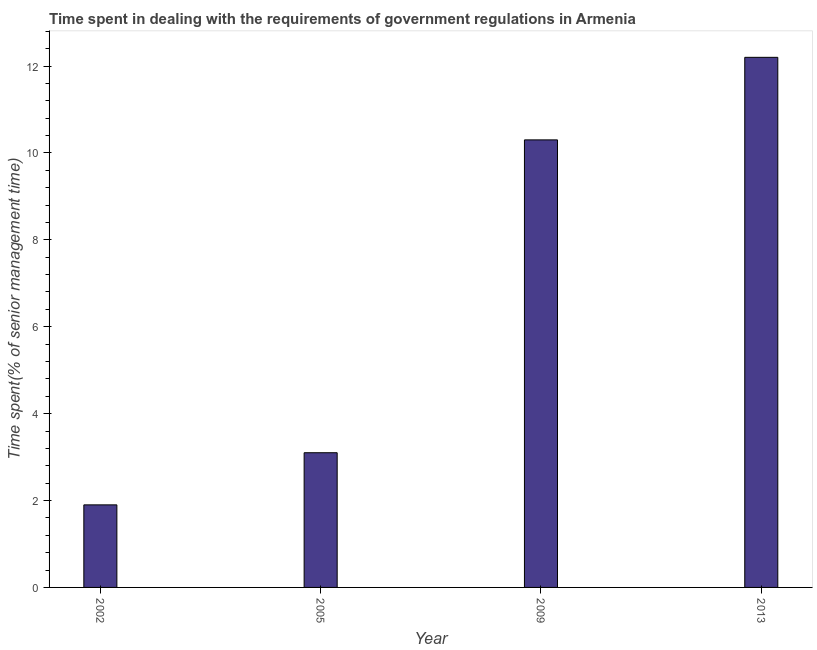Does the graph contain any zero values?
Provide a short and direct response. No. Does the graph contain grids?
Make the answer very short. No. What is the title of the graph?
Your answer should be very brief. Time spent in dealing with the requirements of government regulations in Armenia. What is the label or title of the X-axis?
Your response must be concise. Year. What is the label or title of the Y-axis?
Offer a very short reply. Time spent(% of senior management time). Across all years, what is the maximum time spent in dealing with government regulations?
Your response must be concise. 12.2. In which year was the time spent in dealing with government regulations minimum?
Give a very brief answer. 2002. What is the average time spent in dealing with government regulations per year?
Keep it short and to the point. 6.88. What is the median time spent in dealing with government regulations?
Offer a very short reply. 6.7. Do a majority of the years between 2009 and 2013 (inclusive) have time spent in dealing with government regulations greater than 12 %?
Offer a very short reply. No. What is the ratio of the time spent in dealing with government regulations in 2002 to that in 2005?
Offer a very short reply. 0.61. Is the time spent in dealing with government regulations in 2009 less than that in 2013?
Make the answer very short. Yes. Is the difference between the time spent in dealing with government regulations in 2005 and 2009 greater than the difference between any two years?
Offer a terse response. No. Is the sum of the time spent in dealing with government regulations in 2005 and 2009 greater than the maximum time spent in dealing with government regulations across all years?
Offer a very short reply. Yes. In how many years, is the time spent in dealing with government regulations greater than the average time spent in dealing with government regulations taken over all years?
Keep it short and to the point. 2. How many years are there in the graph?
Your answer should be compact. 4. What is the Time spent(% of senior management time) in 2002?
Offer a terse response. 1.9. What is the Time spent(% of senior management time) of 2009?
Offer a very short reply. 10.3. What is the Time spent(% of senior management time) in 2013?
Ensure brevity in your answer.  12.2. What is the difference between the Time spent(% of senior management time) in 2002 and 2009?
Your response must be concise. -8.4. What is the difference between the Time spent(% of senior management time) in 2002 and 2013?
Keep it short and to the point. -10.3. What is the difference between the Time spent(% of senior management time) in 2005 and 2009?
Provide a short and direct response. -7.2. What is the ratio of the Time spent(% of senior management time) in 2002 to that in 2005?
Provide a short and direct response. 0.61. What is the ratio of the Time spent(% of senior management time) in 2002 to that in 2009?
Offer a very short reply. 0.18. What is the ratio of the Time spent(% of senior management time) in 2002 to that in 2013?
Your answer should be compact. 0.16. What is the ratio of the Time spent(% of senior management time) in 2005 to that in 2009?
Make the answer very short. 0.3. What is the ratio of the Time spent(% of senior management time) in 2005 to that in 2013?
Your answer should be compact. 0.25. What is the ratio of the Time spent(% of senior management time) in 2009 to that in 2013?
Your answer should be compact. 0.84. 